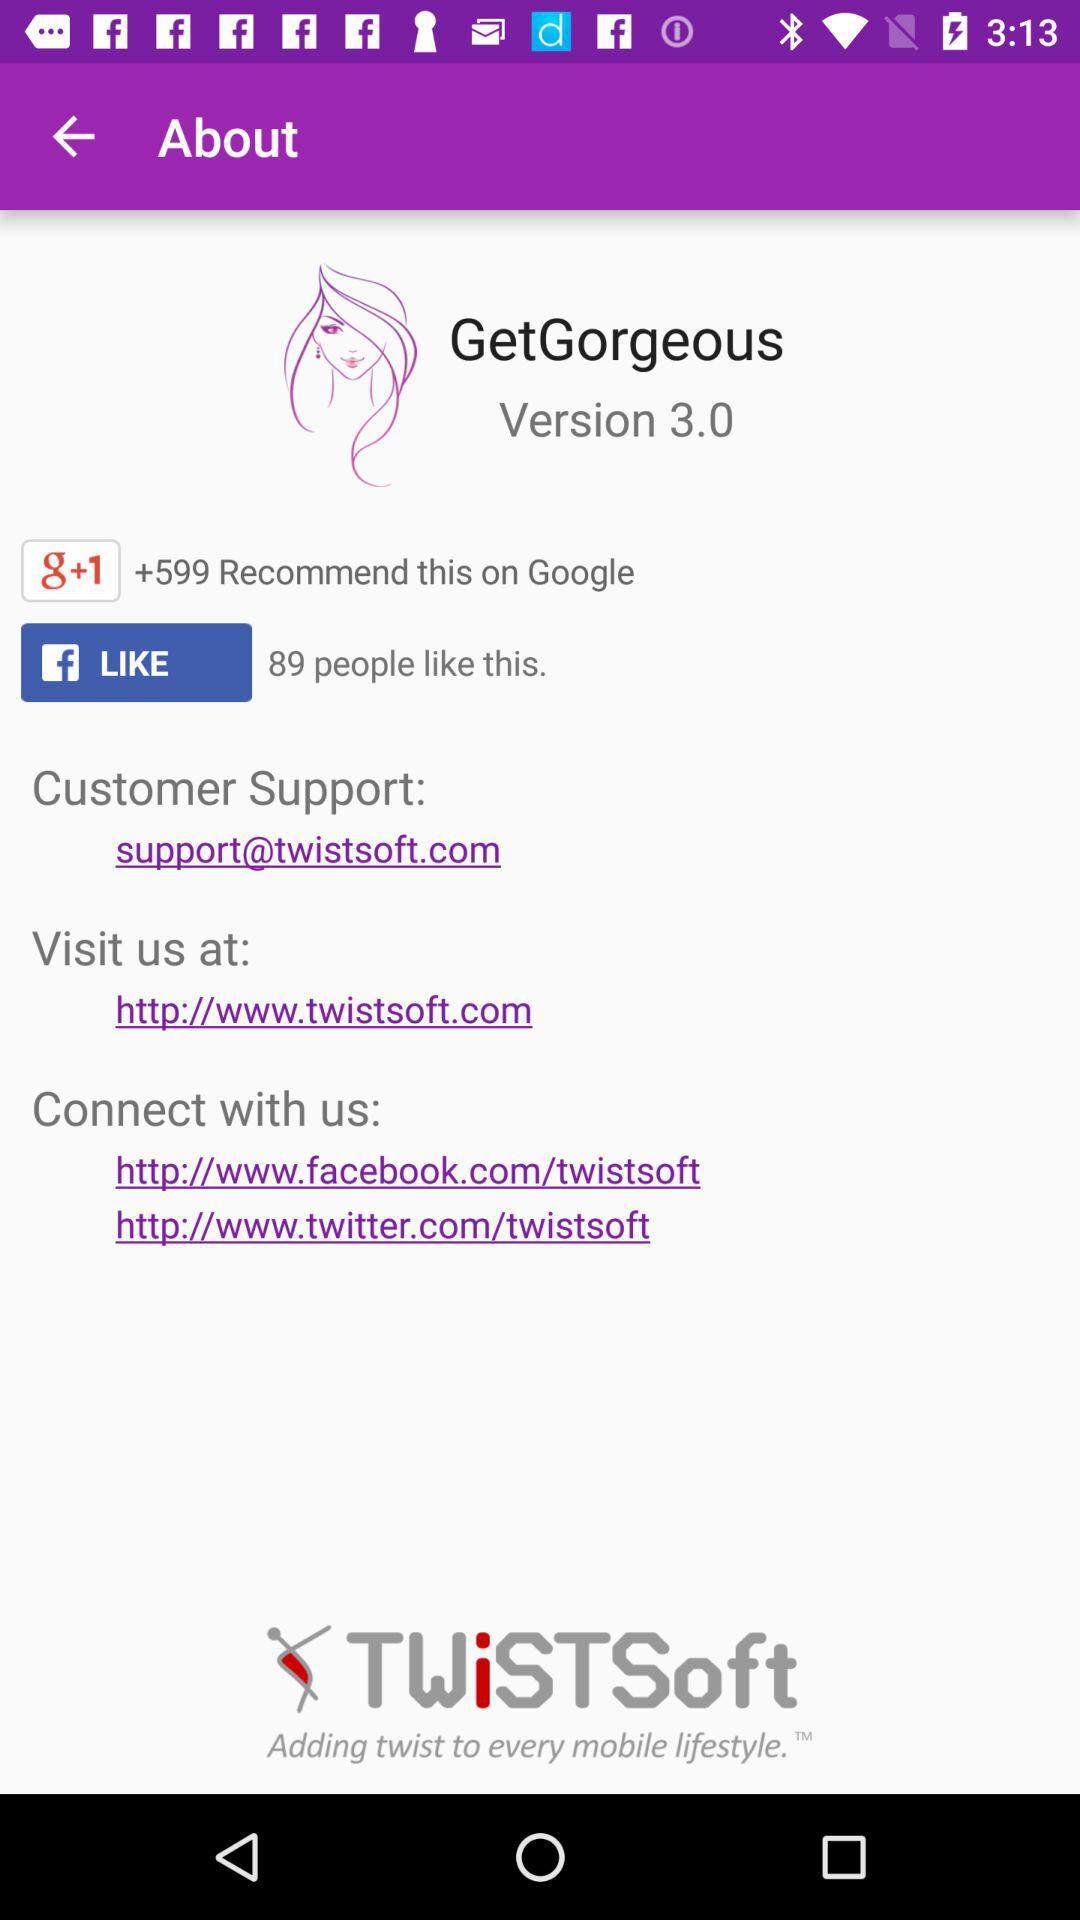How many people recommend the application on "Google Plus"? On "Google Plus", +599 people recommend the application. 